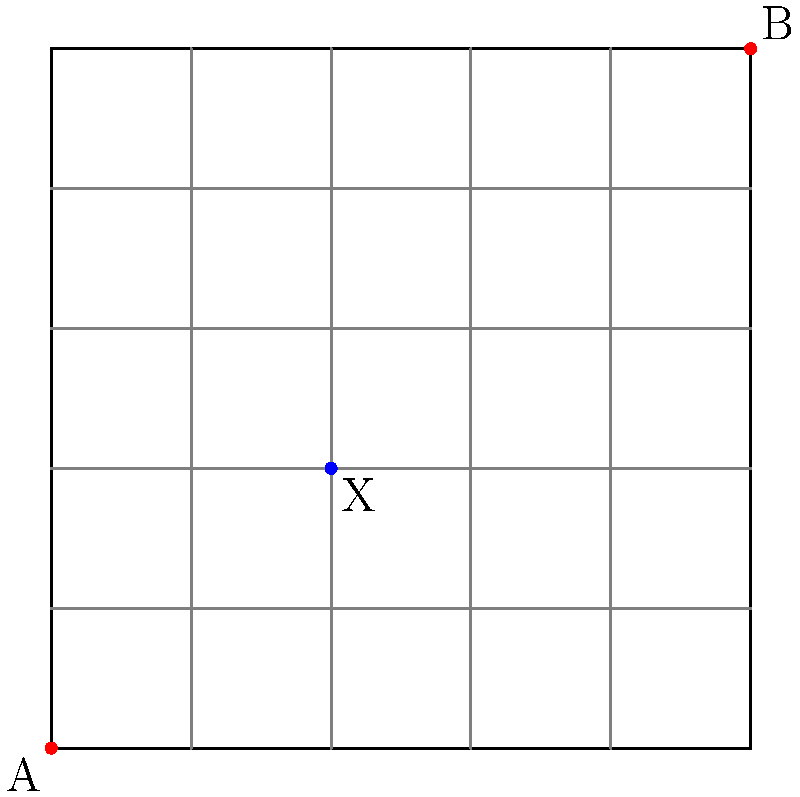Given the city street map above, where A is the starting point and B is the evacuation center, what is the minimum number of blocks that need to be closed to ensure all evacuation routes pass through checkpoint X? To solve this problem, we need to follow these steps:

1. Identify the shortest path from A to B:
   The shortest path is 10 blocks long, moving 5 blocks right and 5 blocks up.

2. Identify all possible shortest paths:
   There are $\binom{10}{5} = 252$ different shortest paths from A to B.

3. Locate checkpoint X:
   X is positioned at (2,2), which is 4 blocks away from both A and B.

4. Determine the minimum number of blocks to close:
   To ensure all routes pass through X, we need to close blocks that would allow paths to bypass X.

5. Calculate blocks to close:
   - Close 2 blocks on the left side of X
   - Close 2 blocks on the right side of X
   - Close 1 block below X
   - Close 1 block above X

Therefore, the minimum number of blocks that need to be closed is 6.

This strategy ensures that any path from A to B must pass through X, optimizing the evacuation route for checkpoint control and resource distribution.
Answer: 6 blocks 